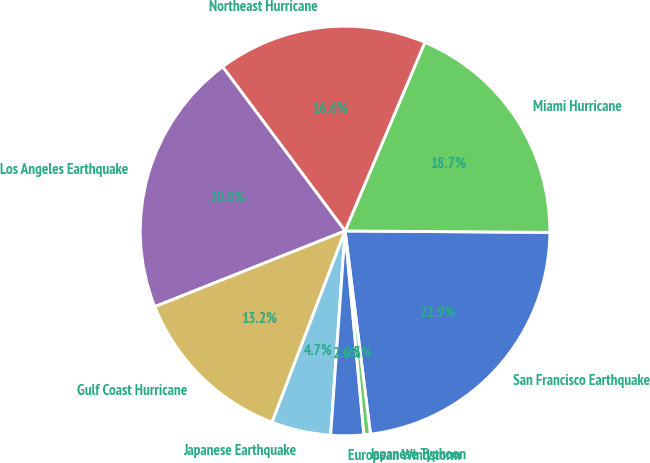<chart> <loc_0><loc_0><loc_500><loc_500><pie_chart><fcel>San Francisco Earthquake<fcel>Miami Hurricane<fcel>Northeast Hurricane<fcel>Los Angeles Earthquake<fcel>Gulf Coast Hurricane<fcel>Japanese Earthquake<fcel>European Windstorm<fcel>Japanese Typhoon<nl><fcel>22.91%<fcel>18.74%<fcel>16.57%<fcel>20.83%<fcel>13.17%<fcel>4.68%<fcel>2.59%<fcel>0.51%<nl></chart> 